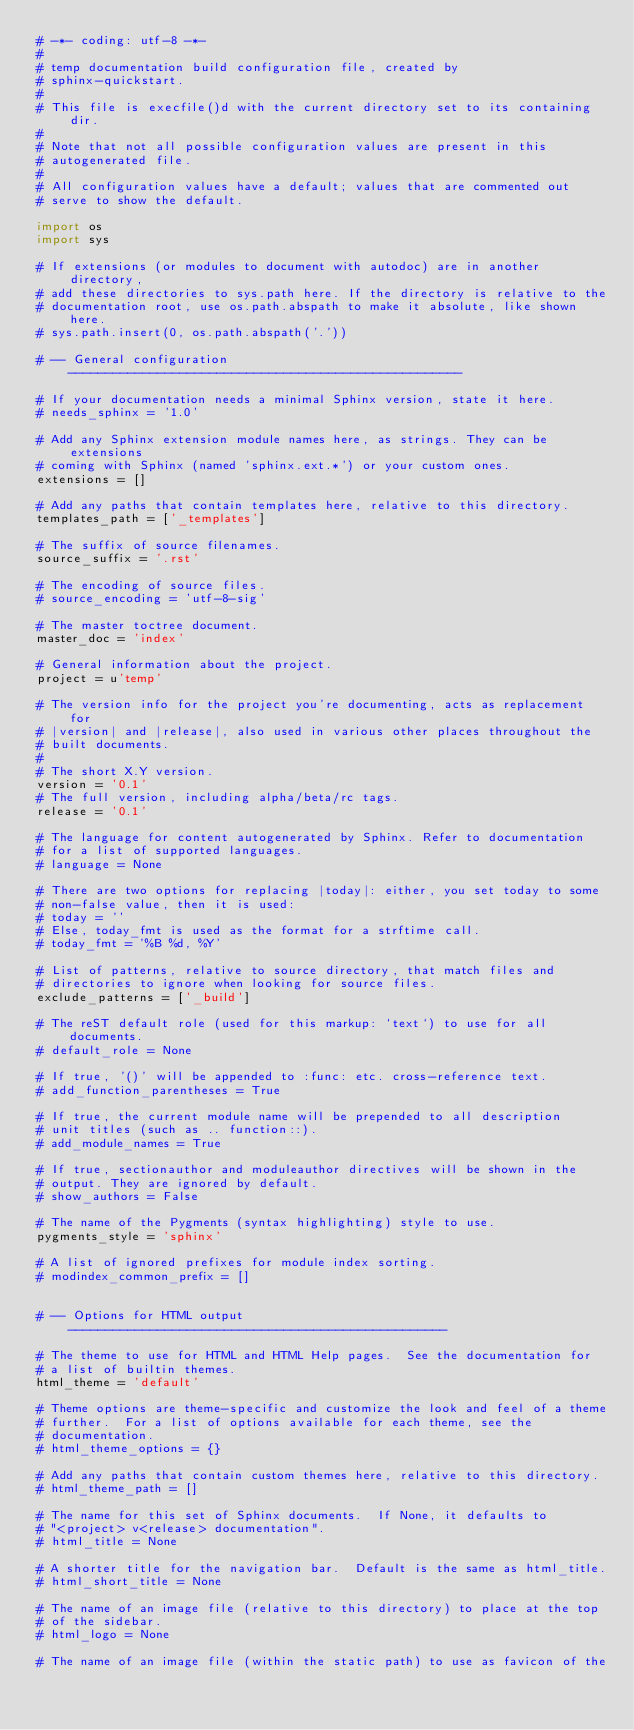Convert code to text. <code><loc_0><loc_0><loc_500><loc_500><_Python_># -*- coding: utf-8 -*-
#
# temp documentation build configuration file, created by
# sphinx-quickstart.
#
# This file is execfile()d with the current directory set to its containing dir.
#
# Note that not all possible configuration values are present in this
# autogenerated file.
#
# All configuration values have a default; values that are commented out
# serve to show the default.

import os
import sys

# If extensions (or modules to document with autodoc) are in another directory,
# add these directories to sys.path here. If the directory is relative to the
# documentation root, use os.path.abspath to make it absolute, like shown here.
# sys.path.insert(0, os.path.abspath('.'))

# -- General configuration -----------------------------------------------------

# If your documentation needs a minimal Sphinx version, state it here.
# needs_sphinx = '1.0'

# Add any Sphinx extension module names here, as strings. They can be extensions
# coming with Sphinx (named 'sphinx.ext.*') or your custom ones.
extensions = []

# Add any paths that contain templates here, relative to this directory.
templates_path = ['_templates']

# The suffix of source filenames.
source_suffix = '.rst'

# The encoding of source files.
# source_encoding = 'utf-8-sig'

# The master toctree document.
master_doc = 'index'

# General information about the project.
project = u'temp'

# The version info for the project you're documenting, acts as replacement for
# |version| and |release|, also used in various other places throughout the
# built documents.
#
# The short X.Y version.
version = '0.1'
# The full version, including alpha/beta/rc tags.
release = '0.1'

# The language for content autogenerated by Sphinx. Refer to documentation
# for a list of supported languages.
# language = None

# There are two options for replacing |today|: either, you set today to some
# non-false value, then it is used:
# today = ''
# Else, today_fmt is used as the format for a strftime call.
# today_fmt = '%B %d, %Y'

# List of patterns, relative to source directory, that match files and
# directories to ignore when looking for source files.
exclude_patterns = ['_build']

# The reST default role (used for this markup: `text`) to use for all documents.
# default_role = None

# If true, '()' will be appended to :func: etc. cross-reference text.
# add_function_parentheses = True

# If true, the current module name will be prepended to all description
# unit titles (such as .. function::).
# add_module_names = True

# If true, sectionauthor and moduleauthor directives will be shown in the
# output. They are ignored by default.
# show_authors = False

# The name of the Pygments (syntax highlighting) style to use.
pygments_style = 'sphinx'

# A list of ignored prefixes for module index sorting.
# modindex_common_prefix = []


# -- Options for HTML output ---------------------------------------------------

# The theme to use for HTML and HTML Help pages.  See the documentation for
# a list of builtin themes.
html_theme = 'default'

# Theme options are theme-specific and customize the look and feel of a theme
# further.  For a list of options available for each theme, see the
# documentation.
# html_theme_options = {}

# Add any paths that contain custom themes here, relative to this directory.
# html_theme_path = []

# The name for this set of Sphinx documents.  If None, it defaults to
# "<project> v<release> documentation".
# html_title = None

# A shorter title for the navigation bar.  Default is the same as html_title.
# html_short_title = None

# The name of an image file (relative to this directory) to place at the top
# of the sidebar.
# html_logo = None

# The name of an image file (within the static path) to use as favicon of the</code> 